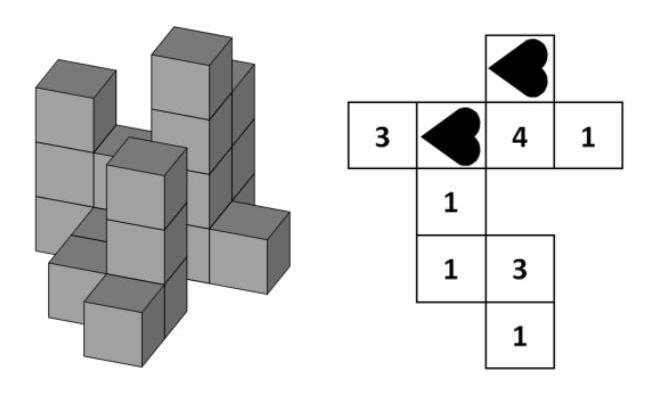Max builds this construction using some small equally big cubes. If he looks at his construction from above, the plan on the right tells the number of cubes in every tower. How big is the sum of the numbers covered by the two hearts?
 Answer is 5. 